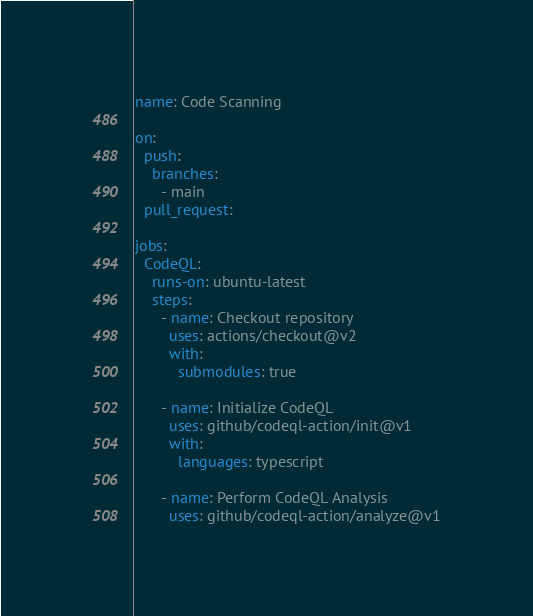Convert code to text. <code><loc_0><loc_0><loc_500><loc_500><_YAML_>name: Code Scanning

on:
  push:
    branches:
      - main
  pull_request:

jobs:
  CodeQL:
    runs-on: ubuntu-latest
    steps:
      - name: Checkout repository
        uses: actions/checkout@v2
        with:
          submodules: true

      - name: Initialize CodeQL
        uses: github/codeql-action/init@v1
        with:
          languages: typescript

      - name: Perform CodeQL Analysis
        uses: github/codeql-action/analyze@v1
</code> 